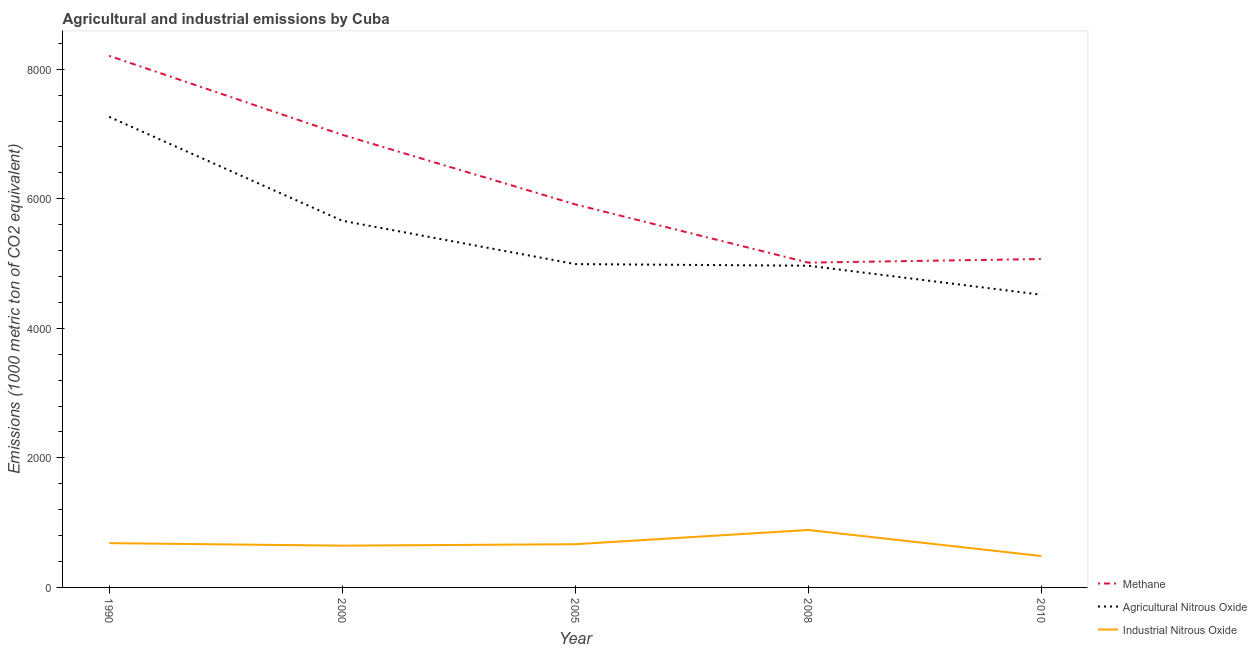How many different coloured lines are there?
Your answer should be very brief. 3. Does the line corresponding to amount of agricultural nitrous oxide emissions intersect with the line corresponding to amount of methane emissions?
Provide a short and direct response. No. Is the number of lines equal to the number of legend labels?
Provide a succinct answer. Yes. What is the amount of industrial nitrous oxide emissions in 2010?
Keep it short and to the point. 484.9. Across all years, what is the maximum amount of industrial nitrous oxide emissions?
Your answer should be very brief. 886.9. Across all years, what is the minimum amount of industrial nitrous oxide emissions?
Offer a very short reply. 484.9. In which year was the amount of industrial nitrous oxide emissions maximum?
Keep it short and to the point. 2008. What is the total amount of industrial nitrous oxide emissions in the graph?
Your answer should be compact. 3367.5. What is the difference between the amount of agricultural nitrous oxide emissions in 1990 and that in 2005?
Your response must be concise. 2273.8. What is the difference between the amount of methane emissions in 2005 and the amount of industrial nitrous oxide emissions in 2000?
Keep it short and to the point. 5268.8. What is the average amount of methane emissions per year?
Your answer should be compact. 6238.96. In the year 2008, what is the difference between the amount of methane emissions and amount of agricultural nitrous oxide emissions?
Keep it short and to the point. 48. What is the ratio of the amount of methane emissions in 2000 to that in 2008?
Keep it short and to the point. 1.39. Is the amount of agricultural nitrous oxide emissions in 1990 less than that in 2005?
Give a very brief answer. No. What is the difference between the highest and the second highest amount of methane emissions?
Your response must be concise. 1219.2. What is the difference between the highest and the lowest amount of industrial nitrous oxide emissions?
Make the answer very short. 402. In how many years, is the amount of agricultural nitrous oxide emissions greater than the average amount of agricultural nitrous oxide emissions taken over all years?
Your answer should be very brief. 2. Does the amount of industrial nitrous oxide emissions monotonically increase over the years?
Your response must be concise. No. How many lines are there?
Offer a very short reply. 3. What is the difference between two consecutive major ticks on the Y-axis?
Give a very brief answer. 2000. Does the graph contain any zero values?
Keep it short and to the point. No. Does the graph contain grids?
Give a very brief answer. No. Where does the legend appear in the graph?
Your answer should be very brief. Bottom right. How many legend labels are there?
Provide a succinct answer. 3. How are the legend labels stacked?
Your answer should be very brief. Vertical. What is the title of the graph?
Your response must be concise. Agricultural and industrial emissions by Cuba. What is the label or title of the X-axis?
Provide a short and direct response. Year. What is the label or title of the Y-axis?
Keep it short and to the point. Emissions (1000 metric ton of CO2 equivalent). What is the Emissions (1000 metric ton of CO2 equivalent) of Methane in 1990?
Ensure brevity in your answer.  8207.5. What is the Emissions (1000 metric ton of CO2 equivalent) in Agricultural Nitrous Oxide in 1990?
Offer a terse response. 7265.9. What is the Emissions (1000 metric ton of CO2 equivalent) in Industrial Nitrous Oxide in 1990?
Make the answer very short. 683.6. What is the Emissions (1000 metric ton of CO2 equivalent) in Methane in 2000?
Offer a terse response. 6988.3. What is the Emissions (1000 metric ton of CO2 equivalent) of Agricultural Nitrous Oxide in 2000?
Make the answer very short. 5661.3. What is the Emissions (1000 metric ton of CO2 equivalent) in Industrial Nitrous Oxide in 2000?
Provide a succinct answer. 645. What is the Emissions (1000 metric ton of CO2 equivalent) of Methane in 2005?
Your answer should be very brief. 5913.8. What is the Emissions (1000 metric ton of CO2 equivalent) of Agricultural Nitrous Oxide in 2005?
Your answer should be compact. 4992.1. What is the Emissions (1000 metric ton of CO2 equivalent) of Industrial Nitrous Oxide in 2005?
Your response must be concise. 667.1. What is the Emissions (1000 metric ton of CO2 equivalent) of Methane in 2008?
Your answer should be very brief. 5015. What is the Emissions (1000 metric ton of CO2 equivalent) in Agricultural Nitrous Oxide in 2008?
Provide a succinct answer. 4967. What is the Emissions (1000 metric ton of CO2 equivalent) of Industrial Nitrous Oxide in 2008?
Provide a succinct answer. 886.9. What is the Emissions (1000 metric ton of CO2 equivalent) of Methane in 2010?
Make the answer very short. 5070.2. What is the Emissions (1000 metric ton of CO2 equivalent) in Agricultural Nitrous Oxide in 2010?
Your answer should be very brief. 4519.3. What is the Emissions (1000 metric ton of CO2 equivalent) of Industrial Nitrous Oxide in 2010?
Make the answer very short. 484.9. Across all years, what is the maximum Emissions (1000 metric ton of CO2 equivalent) of Methane?
Your answer should be very brief. 8207.5. Across all years, what is the maximum Emissions (1000 metric ton of CO2 equivalent) of Agricultural Nitrous Oxide?
Make the answer very short. 7265.9. Across all years, what is the maximum Emissions (1000 metric ton of CO2 equivalent) of Industrial Nitrous Oxide?
Your response must be concise. 886.9. Across all years, what is the minimum Emissions (1000 metric ton of CO2 equivalent) in Methane?
Provide a succinct answer. 5015. Across all years, what is the minimum Emissions (1000 metric ton of CO2 equivalent) in Agricultural Nitrous Oxide?
Your response must be concise. 4519.3. Across all years, what is the minimum Emissions (1000 metric ton of CO2 equivalent) in Industrial Nitrous Oxide?
Provide a succinct answer. 484.9. What is the total Emissions (1000 metric ton of CO2 equivalent) of Methane in the graph?
Offer a very short reply. 3.12e+04. What is the total Emissions (1000 metric ton of CO2 equivalent) of Agricultural Nitrous Oxide in the graph?
Give a very brief answer. 2.74e+04. What is the total Emissions (1000 metric ton of CO2 equivalent) in Industrial Nitrous Oxide in the graph?
Offer a very short reply. 3367.5. What is the difference between the Emissions (1000 metric ton of CO2 equivalent) of Methane in 1990 and that in 2000?
Give a very brief answer. 1219.2. What is the difference between the Emissions (1000 metric ton of CO2 equivalent) of Agricultural Nitrous Oxide in 1990 and that in 2000?
Keep it short and to the point. 1604.6. What is the difference between the Emissions (1000 metric ton of CO2 equivalent) of Industrial Nitrous Oxide in 1990 and that in 2000?
Your answer should be compact. 38.6. What is the difference between the Emissions (1000 metric ton of CO2 equivalent) of Methane in 1990 and that in 2005?
Offer a terse response. 2293.7. What is the difference between the Emissions (1000 metric ton of CO2 equivalent) in Agricultural Nitrous Oxide in 1990 and that in 2005?
Offer a terse response. 2273.8. What is the difference between the Emissions (1000 metric ton of CO2 equivalent) of Methane in 1990 and that in 2008?
Offer a very short reply. 3192.5. What is the difference between the Emissions (1000 metric ton of CO2 equivalent) of Agricultural Nitrous Oxide in 1990 and that in 2008?
Your response must be concise. 2298.9. What is the difference between the Emissions (1000 metric ton of CO2 equivalent) of Industrial Nitrous Oxide in 1990 and that in 2008?
Give a very brief answer. -203.3. What is the difference between the Emissions (1000 metric ton of CO2 equivalent) of Methane in 1990 and that in 2010?
Ensure brevity in your answer.  3137.3. What is the difference between the Emissions (1000 metric ton of CO2 equivalent) of Agricultural Nitrous Oxide in 1990 and that in 2010?
Offer a very short reply. 2746.6. What is the difference between the Emissions (1000 metric ton of CO2 equivalent) in Industrial Nitrous Oxide in 1990 and that in 2010?
Your answer should be very brief. 198.7. What is the difference between the Emissions (1000 metric ton of CO2 equivalent) of Methane in 2000 and that in 2005?
Keep it short and to the point. 1074.5. What is the difference between the Emissions (1000 metric ton of CO2 equivalent) in Agricultural Nitrous Oxide in 2000 and that in 2005?
Give a very brief answer. 669.2. What is the difference between the Emissions (1000 metric ton of CO2 equivalent) in Industrial Nitrous Oxide in 2000 and that in 2005?
Provide a short and direct response. -22.1. What is the difference between the Emissions (1000 metric ton of CO2 equivalent) in Methane in 2000 and that in 2008?
Your response must be concise. 1973.3. What is the difference between the Emissions (1000 metric ton of CO2 equivalent) of Agricultural Nitrous Oxide in 2000 and that in 2008?
Keep it short and to the point. 694.3. What is the difference between the Emissions (1000 metric ton of CO2 equivalent) in Industrial Nitrous Oxide in 2000 and that in 2008?
Your answer should be very brief. -241.9. What is the difference between the Emissions (1000 metric ton of CO2 equivalent) in Methane in 2000 and that in 2010?
Keep it short and to the point. 1918.1. What is the difference between the Emissions (1000 metric ton of CO2 equivalent) of Agricultural Nitrous Oxide in 2000 and that in 2010?
Provide a short and direct response. 1142. What is the difference between the Emissions (1000 metric ton of CO2 equivalent) of Industrial Nitrous Oxide in 2000 and that in 2010?
Your response must be concise. 160.1. What is the difference between the Emissions (1000 metric ton of CO2 equivalent) of Methane in 2005 and that in 2008?
Your answer should be compact. 898.8. What is the difference between the Emissions (1000 metric ton of CO2 equivalent) of Agricultural Nitrous Oxide in 2005 and that in 2008?
Give a very brief answer. 25.1. What is the difference between the Emissions (1000 metric ton of CO2 equivalent) of Industrial Nitrous Oxide in 2005 and that in 2008?
Give a very brief answer. -219.8. What is the difference between the Emissions (1000 metric ton of CO2 equivalent) in Methane in 2005 and that in 2010?
Provide a succinct answer. 843.6. What is the difference between the Emissions (1000 metric ton of CO2 equivalent) of Agricultural Nitrous Oxide in 2005 and that in 2010?
Keep it short and to the point. 472.8. What is the difference between the Emissions (1000 metric ton of CO2 equivalent) of Industrial Nitrous Oxide in 2005 and that in 2010?
Provide a short and direct response. 182.2. What is the difference between the Emissions (1000 metric ton of CO2 equivalent) in Methane in 2008 and that in 2010?
Your response must be concise. -55.2. What is the difference between the Emissions (1000 metric ton of CO2 equivalent) in Agricultural Nitrous Oxide in 2008 and that in 2010?
Give a very brief answer. 447.7. What is the difference between the Emissions (1000 metric ton of CO2 equivalent) in Industrial Nitrous Oxide in 2008 and that in 2010?
Provide a succinct answer. 402. What is the difference between the Emissions (1000 metric ton of CO2 equivalent) of Methane in 1990 and the Emissions (1000 metric ton of CO2 equivalent) of Agricultural Nitrous Oxide in 2000?
Offer a terse response. 2546.2. What is the difference between the Emissions (1000 metric ton of CO2 equivalent) of Methane in 1990 and the Emissions (1000 metric ton of CO2 equivalent) of Industrial Nitrous Oxide in 2000?
Provide a short and direct response. 7562.5. What is the difference between the Emissions (1000 metric ton of CO2 equivalent) of Agricultural Nitrous Oxide in 1990 and the Emissions (1000 metric ton of CO2 equivalent) of Industrial Nitrous Oxide in 2000?
Keep it short and to the point. 6620.9. What is the difference between the Emissions (1000 metric ton of CO2 equivalent) in Methane in 1990 and the Emissions (1000 metric ton of CO2 equivalent) in Agricultural Nitrous Oxide in 2005?
Your answer should be compact. 3215.4. What is the difference between the Emissions (1000 metric ton of CO2 equivalent) in Methane in 1990 and the Emissions (1000 metric ton of CO2 equivalent) in Industrial Nitrous Oxide in 2005?
Give a very brief answer. 7540.4. What is the difference between the Emissions (1000 metric ton of CO2 equivalent) of Agricultural Nitrous Oxide in 1990 and the Emissions (1000 metric ton of CO2 equivalent) of Industrial Nitrous Oxide in 2005?
Provide a succinct answer. 6598.8. What is the difference between the Emissions (1000 metric ton of CO2 equivalent) of Methane in 1990 and the Emissions (1000 metric ton of CO2 equivalent) of Agricultural Nitrous Oxide in 2008?
Keep it short and to the point. 3240.5. What is the difference between the Emissions (1000 metric ton of CO2 equivalent) in Methane in 1990 and the Emissions (1000 metric ton of CO2 equivalent) in Industrial Nitrous Oxide in 2008?
Offer a terse response. 7320.6. What is the difference between the Emissions (1000 metric ton of CO2 equivalent) in Agricultural Nitrous Oxide in 1990 and the Emissions (1000 metric ton of CO2 equivalent) in Industrial Nitrous Oxide in 2008?
Give a very brief answer. 6379. What is the difference between the Emissions (1000 metric ton of CO2 equivalent) of Methane in 1990 and the Emissions (1000 metric ton of CO2 equivalent) of Agricultural Nitrous Oxide in 2010?
Offer a terse response. 3688.2. What is the difference between the Emissions (1000 metric ton of CO2 equivalent) in Methane in 1990 and the Emissions (1000 metric ton of CO2 equivalent) in Industrial Nitrous Oxide in 2010?
Make the answer very short. 7722.6. What is the difference between the Emissions (1000 metric ton of CO2 equivalent) in Agricultural Nitrous Oxide in 1990 and the Emissions (1000 metric ton of CO2 equivalent) in Industrial Nitrous Oxide in 2010?
Your answer should be very brief. 6781. What is the difference between the Emissions (1000 metric ton of CO2 equivalent) of Methane in 2000 and the Emissions (1000 metric ton of CO2 equivalent) of Agricultural Nitrous Oxide in 2005?
Your answer should be very brief. 1996.2. What is the difference between the Emissions (1000 metric ton of CO2 equivalent) of Methane in 2000 and the Emissions (1000 metric ton of CO2 equivalent) of Industrial Nitrous Oxide in 2005?
Offer a terse response. 6321.2. What is the difference between the Emissions (1000 metric ton of CO2 equivalent) of Agricultural Nitrous Oxide in 2000 and the Emissions (1000 metric ton of CO2 equivalent) of Industrial Nitrous Oxide in 2005?
Provide a short and direct response. 4994.2. What is the difference between the Emissions (1000 metric ton of CO2 equivalent) of Methane in 2000 and the Emissions (1000 metric ton of CO2 equivalent) of Agricultural Nitrous Oxide in 2008?
Ensure brevity in your answer.  2021.3. What is the difference between the Emissions (1000 metric ton of CO2 equivalent) in Methane in 2000 and the Emissions (1000 metric ton of CO2 equivalent) in Industrial Nitrous Oxide in 2008?
Give a very brief answer. 6101.4. What is the difference between the Emissions (1000 metric ton of CO2 equivalent) in Agricultural Nitrous Oxide in 2000 and the Emissions (1000 metric ton of CO2 equivalent) in Industrial Nitrous Oxide in 2008?
Provide a succinct answer. 4774.4. What is the difference between the Emissions (1000 metric ton of CO2 equivalent) of Methane in 2000 and the Emissions (1000 metric ton of CO2 equivalent) of Agricultural Nitrous Oxide in 2010?
Keep it short and to the point. 2469. What is the difference between the Emissions (1000 metric ton of CO2 equivalent) in Methane in 2000 and the Emissions (1000 metric ton of CO2 equivalent) in Industrial Nitrous Oxide in 2010?
Offer a very short reply. 6503.4. What is the difference between the Emissions (1000 metric ton of CO2 equivalent) of Agricultural Nitrous Oxide in 2000 and the Emissions (1000 metric ton of CO2 equivalent) of Industrial Nitrous Oxide in 2010?
Your answer should be very brief. 5176.4. What is the difference between the Emissions (1000 metric ton of CO2 equivalent) in Methane in 2005 and the Emissions (1000 metric ton of CO2 equivalent) in Agricultural Nitrous Oxide in 2008?
Offer a very short reply. 946.8. What is the difference between the Emissions (1000 metric ton of CO2 equivalent) in Methane in 2005 and the Emissions (1000 metric ton of CO2 equivalent) in Industrial Nitrous Oxide in 2008?
Provide a succinct answer. 5026.9. What is the difference between the Emissions (1000 metric ton of CO2 equivalent) of Agricultural Nitrous Oxide in 2005 and the Emissions (1000 metric ton of CO2 equivalent) of Industrial Nitrous Oxide in 2008?
Offer a very short reply. 4105.2. What is the difference between the Emissions (1000 metric ton of CO2 equivalent) of Methane in 2005 and the Emissions (1000 metric ton of CO2 equivalent) of Agricultural Nitrous Oxide in 2010?
Provide a succinct answer. 1394.5. What is the difference between the Emissions (1000 metric ton of CO2 equivalent) in Methane in 2005 and the Emissions (1000 metric ton of CO2 equivalent) in Industrial Nitrous Oxide in 2010?
Offer a very short reply. 5428.9. What is the difference between the Emissions (1000 metric ton of CO2 equivalent) in Agricultural Nitrous Oxide in 2005 and the Emissions (1000 metric ton of CO2 equivalent) in Industrial Nitrous Oxide in 2010?
Offer a very short reply. 4507.2. What is the difference between the Emissions (1000 metric ton of CO2 equivalent) of Methane in 2008 and the Emissions (1000 metric ton of CO2 equivalent) of Agricultural Nitrous Oxide in 2010?
Keep it short and to the point. 495.7. What is the difference between the Emissions (1000 metric ton of CO2 equivalent) of Methane in 2008 and the Emissions (1000 metric ton of CO2 equivalent) of Industrial Nitrous Oxide in 2010?
Provide a succinct answer. 4530.1. What is the difference between the Emissions (1000 metric ton of CO2 equivalent) in Agricultural Nitrous Oxide in 2008 and the Emissions (1000 metric ton of CO2 equivalent) in Industrial Nitrous Oxide in 2010?
Your response must be concise. 4482.1. What is the average Emissions (1000 metric ton of CO2 equivalent) of Methane per year?
Offer a terse response. 6238.96. What is the average Emissions (1000 metric ton of CO2 equivalent) of Agricultural Nitrous Oxide per year?
Ensure brevity in your answer.  5481.12. What is the average Emissions (1000 metric ton of CO2 equivalent) in Industrial Nitrous Oxide per year?
Keep it short and to the point. 673.5. In the year 1990, what is the difference between the Emissions (1000 metric ton of CO2 equivalent) in Methane and Emissions (1000 metric ton of CO2 equivalent) in Agricultural Nitrous Oxide?
Keep it short and to the point. 941.6. In the year 1990, what is the difference between the Emissions (1000 metric ton of CO2 equivalent) of Methane and Emissions (1000 metric ton of CO2 equivalent) of Industrial Nitrous Oxide?
Provide a short and direct response. 7523.9. In the year 1990, what is the difference between the Emissions (1000 metric ton of CO2 equivalent) in Agricultural Nitrous Oxide and Emissions (1000 metric ton of CO2 equivalent) in Industrial Nitrous Oxide?
Ensure brevity in your answer.  6582.3. In the year 2000, what is the difference between the Emissions (1000 metric ton of CO2 equivalent) of Methane and Emissions (1000 metric ton of CO2 equivalent) of Agricultural Nitrous Oxide?
Your answer should be compact. 1327. In the year 2000, what is the difference between the Emissions (1000 metric ton of CO2 equivalent) of Methane and Emissions (1000 metric ton of CO2 equivalent) of Industrial Nitrous Oxide?
Your answer should be compact. 6343.3. In the year 2000, what is the difference between the Emissions (1000 metric ton of CO2 equivalent) of Agricultural Nitrous Oxide and Emissions (1000 metric ton of CO2 equivalent) of Industrial Nitrous Oxide?
Ensure brevity in your answer.  5016.3. In the year 2005, what is the difference between the Emissions (1000 metric ton of CO2 equivalent) of Methane and Emissions (1000 metric ton of CO2 equivalent) of Agricultural Nitrous Oxide?
Provide a short and direct response. 921.7. In the year 2005, what is the difference between the Emissions (1000 metric ton of CO2 equivalent) of Methane and Emissions (1000 metric ton of CO2 equivalent) of Industrial Nitrous Oxide?
Keep it short and to the point. 5246.7. In the year 2005, what is the difference between the Emissions (1000 metric ton of CO2 equivalent) in Agricultural Nitrous Oxide and Emissions (1000 metric ton of CO2 equivalent) in Industrial Nitrous Oxide?
Your response must be concise. 4325. In the year 2008, what is the difference between the Emissions (1000 metric ton of CO2 equivalent) in Methane and Emissions (1000 metric ton of CO2 equivalent) in Agricultural Nitrous Oxide?
Give a very brief answer. 48. In the year 2008, what is the difference between the Emissions (1000 metric ton of CO2 equivalent) of Methane and Emissions (1000 metric ton of CO2 equivalent) of Industrial Nitrous Oxide?
Give a very brief answer. 4128.1. In the year 2008, what is the difference between the Emissions (1000 metric ton of CO2 equivalent) in Agricultural Nitrous Oxide and Emissions (1000 metric ton of CO2 equivalent) in Industrial Nitrous Oxide?
Provide a succinct answer. 4080.1. In the year 2010, what is the difference between the Emissions (1000 metric ton of CO2 equivalent) in Methane and Emissions (1000 metric ton of CO2 equivalent) in Agricultural Nitrous Oxide?
Give a very brief answer. 550.9. In the year 2010, what is the difference between the Emissions (1000 metric ton of CO2 equivalent) of Methane and Emissions (1000 metric ton of CO2 equivalent) of Industrial Nitrous Oxide?
Your answer should be very brief. 4585.3. In the year 2010, what is the difference between the Emissions (1000 metric ton of CO2 equivalent) of Agricultural Nitrous Oxide and Emissions (1000 metric ton of CO2 equivalent) of Industrial Nitrous Oxide?
Your answer should be compact. 4034.4. What is the ratio of the Emissions (1000 metric ton of CO2 equivalent) in Methane in 1990 to that in 2000?
Ensure brevity in your answer.  1.17. What is the ratio of the Emissions (1000 metric ton of CO2 equivalent) in Agricultural Nitrous Oxide in 1990 to that in 2000?
Offer a very short reply. 1.28. What is the ratio of the Emissions (1000 metric ton of CO2 equivalent) of Industrial Nitrous Oxide in 1990 to that in 2000?
Provide a short and direct response. 1.06. What is the ratio of the Emissions (1000 metric ton of CO2 equivalent) of Methane in 1990 to that in 2005?
Give a very brief answer. 1.39. What is the ratio of the Emissions (1000 metric ton of CO2 equivalent) in Agricultural Nitrous Oxide in 1990 to that in 2005?
Make the answer very short. 1.46. What is the ratio of the Emissions (1000 metric ton of CO2 equivalent) of Industrial Nitrous Oxide in 1990 to that in 2005?
Give a very brief answer. 1.02. What is the ratio of the Emissions (1000 metric ton of CO2 equivalent) in Methane in 1990 to that in 2008?
Ensure brevity in your answer.  1.64. What is the ratio of the Emissions (1000 metric ton of CO2 equivalent) in Agricultural Nitrous Oxide in 1990 to that in 2008?
Ensure brevity in your answer.  1.46. What is the ratio of the Emissions (1000 metric ton of CO2 equivalent) of Industrial Nitrous Oxide in 1990 to that in 2008?
Offer a very short reply. 0.77. What is the ratio of the Emissions (1000 metric ton of CO2 equivalent) of Methane in 1990 to that in 2010?
Your response must be concise. 1.62. What is the ratio of the Emissions (1000 metric ton of CO2 equivalent) of Agricultural Nitrous Oxide in 1990 to that in 2010?
Offer a terse response. 1.61. What is the ratio of the Emissions (1000 metric ton of CO2 equivalent) in Industrial Nitrous Oxide in 1990 to that in 2010?
Keep it short and to the point. 1.41. What is the ratio of the Emissions (1000 metric ton of CO2 equivalent) in Methane in 2000 to that in 2005?
Your answer should be compact. 1.18. What is the ratio of the Emissions (1000 metric ton of CO2 equivalent) of Agricultural Nitrous Oxide in 2000 to that in 2005?
Provide a succinct answer. 1.13. What is the ratio of the Emissions (1000 metric ton of CO2 equivalent) in Industrial Nitrous Oxide in 2000 to that in 2005?
Your answer should be very brief. 0.97. What is the ratio of the Emissions (1000 metric ton of CO2 equivalent) of Methane in 2000 to that in 2008?
Offer a terse response. 1.39. What is the ratio of the Emissions (1000 metric ton of CO2 equivalent) of Agricultural Nitrous Oxide in 2000 to that in 2008?
Provide a succinct answer. 1.14. What is the ratio of the Emissions (1000 metric ton of CO2 equivalent) of Industrial Nitrous Oxide in 2000 to that in 2008?
Make the answer very short. 0.73. What is the ratio of the Emissions (1000 metric ton of CO2 equivalent) of Methane in 2000 to that in 2010?
Provide a short and direct response. 1.38. What is the ratio of the Emissions (1000 metric ton of CO2 equivalent) of Agricultural Nitrous Oxide in 2000 to that in 2010?
Your answer should be compact. 1.25. What is the ratio of the Emissions (1000 metric ton of CO2 equivalent) in Industrial Nitrous Oxide in 2000 to that in 2010?
Offer a very short reply. 1.33. What is the ratio of the Emissions (1000 metric ton of CO2 equivalent) in Methane in 2005 to that in 2008?
Ensure brevity in your answer.  1.18. What is the ratio of the Emissions (1000 metric ton of CO2 equivalent) in Industrial Nitrous Oxide in 2005 to that in 2008?
Your answer should be compact. 0.75. What is the ratio of the Emissions (1000 metric ton of CO2 equivalent) in Methane in 2005 to that in 2010?
Keep it short and to the point. 1.17. What is the ratio of the Emissions (1000 metric ton of CO2 equivalent) in Agricultural Nitrous Oxide in 2005 to that in 2010?
Give a very brief answer. 1.1. What is the ratio of the Emissions (1000 metric ton of CO2 equivalent) of Industrial Nitrous Oxide in 2005 to that in 2010?
Provide a succinct answer. 1.38. What is the ratio of the Emissions (1000 metric ton of CO2 equivalent) of Methane in 2008 to that in 2010?
Make the answer very short. 0.99. What is the ratio of the Emissions (1000 metric ton of CO2 equivalent) in Agricultural Nitrous Oxide in 2008 to that in 2010?
Your answer should be compact. 1.1. What is the ratio of the Emissions (1000 metric ton of CO2 equivalent) in Industrial Nitrous Oxide in 2008 to that in 2010?
Provide a short and direct response. 1.83. What is the difference between the highest and the second highest Emissions (1000 metric ton of CO2 equivalent) in Methane?
Ensure brevity in your answer.  1219.2. What is the difference between the highest and the second highest Emissions (1000 metric ton of CO2 equivalent) in Agricultural Nitrous Oxide?
Ensure brevity in your answer.  1604.6. What is the difference between the highest and the second highest Emissions (1000 metric ton of CO2 equivalent) in Industrial Nitrous Oxide?
Make the answer very short. 203.3. What is the difference between the highest and the lowest Emissions (1000 metric ton of CO2 equivalent) in Methane?
Offer a terse response. 3192.5. What is the difference between the highest and the lowest Emissions (1000 metric ton of CO2 equivalent) of Agricultural Nitrous Oxide?
Offer a very short reply. 2746.6. What is the difference between the highest and the lowest Emissions (1000 metric ton of CO2 equivalent) of Industrial Nitrous Oxide?
Provide a succinct answer. 402. 